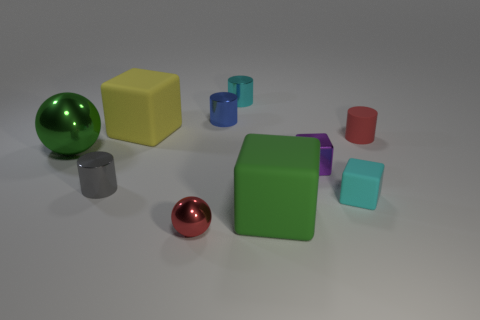There is a metallic cylinder that is left of the red metallic thing; how big is it?
Your answer should be compact. Small. What number of other objects are the same color as the small matte cylinder?
Offer a terse response. 1. There is a large green object to the right of the small shiny cylinder that is on the left side of the tiny blue cylinder; what is it made of?
Your response must be concise. Rubber. There is a metal object in front of the tiny gray metallic thing; does it have the same color as the tiny rubber cylinder?
Your answer should be very brief. Yes. How many tiny red things are the same shape as the gray thing?
Your response must be concise. 1. The gray cylinder that is the same material as the tiny purple object is what size?
Keep it short and to the point. Small. Are there any tiny blue metal objects that are in front of the big rubber block to the left of the small shiny thing in front of the green matte thing?
Offer a very short reply. No. There is a block that is to the left of the red metal ball; does it have the same size as the cyan block?
Provide a succinct answer. No. What number of things have the same size as the green sphere?
Give a very brief answer. 2. What is the size of the other thing that is the same color as the big metal thing?
Your answer should be very brief. Large. 